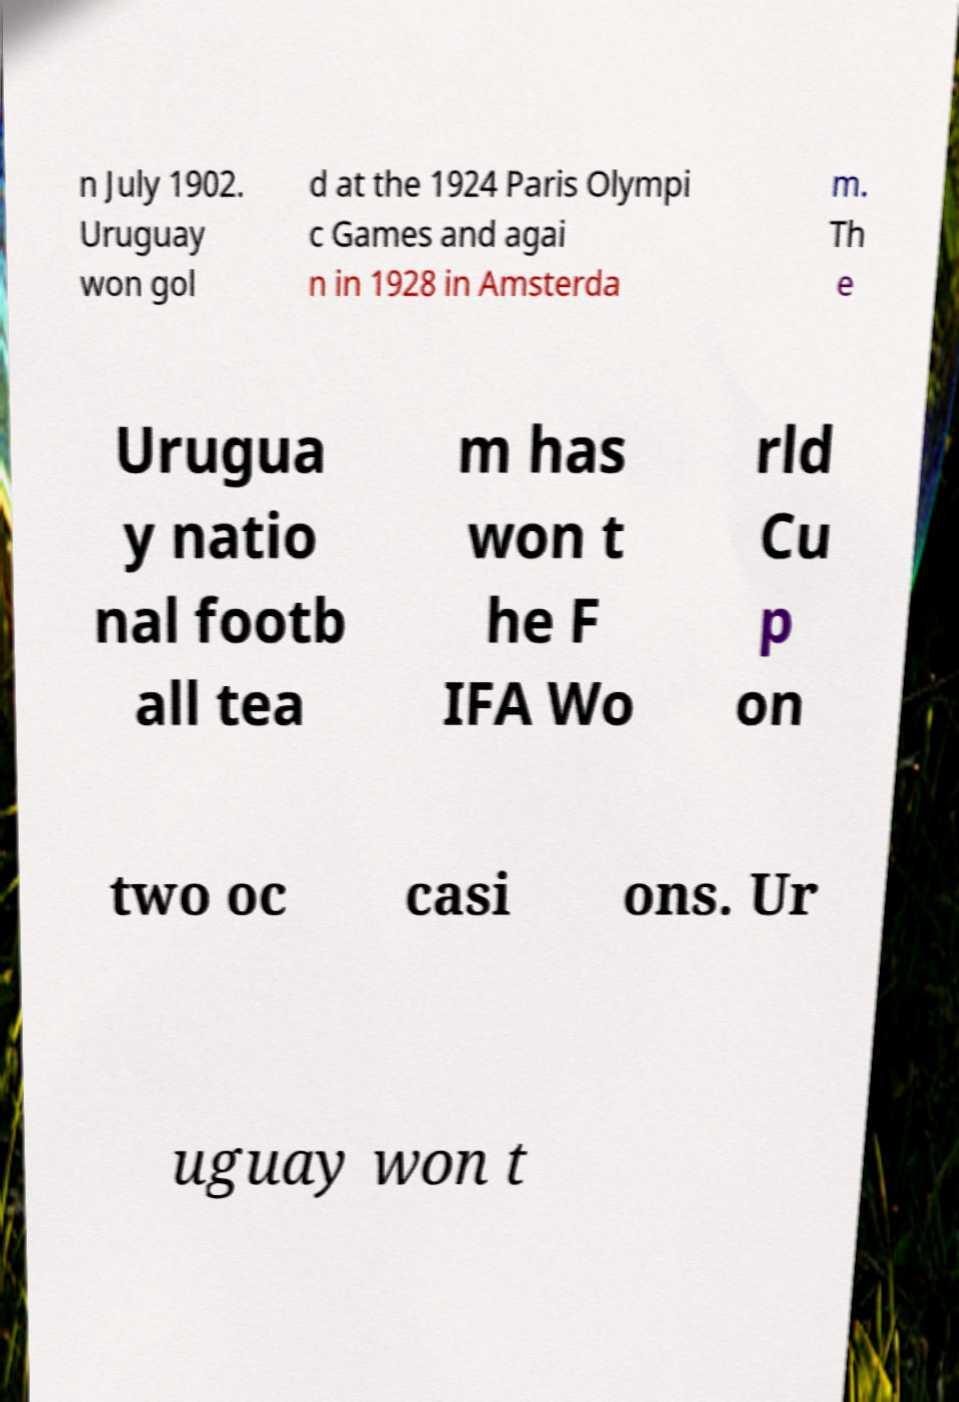What messages or text are displayed in this image? I need them in a readable, typed format. n July 1902. Uruguay won gol d at the 1924 Paris Olympi c Games and agai n in 1928 in Amsterda m. Th e Urugua y natio nal footb all tea m has won t he F IFA Wo rld Cu p on two oc casi ons. Ur uguay won t 